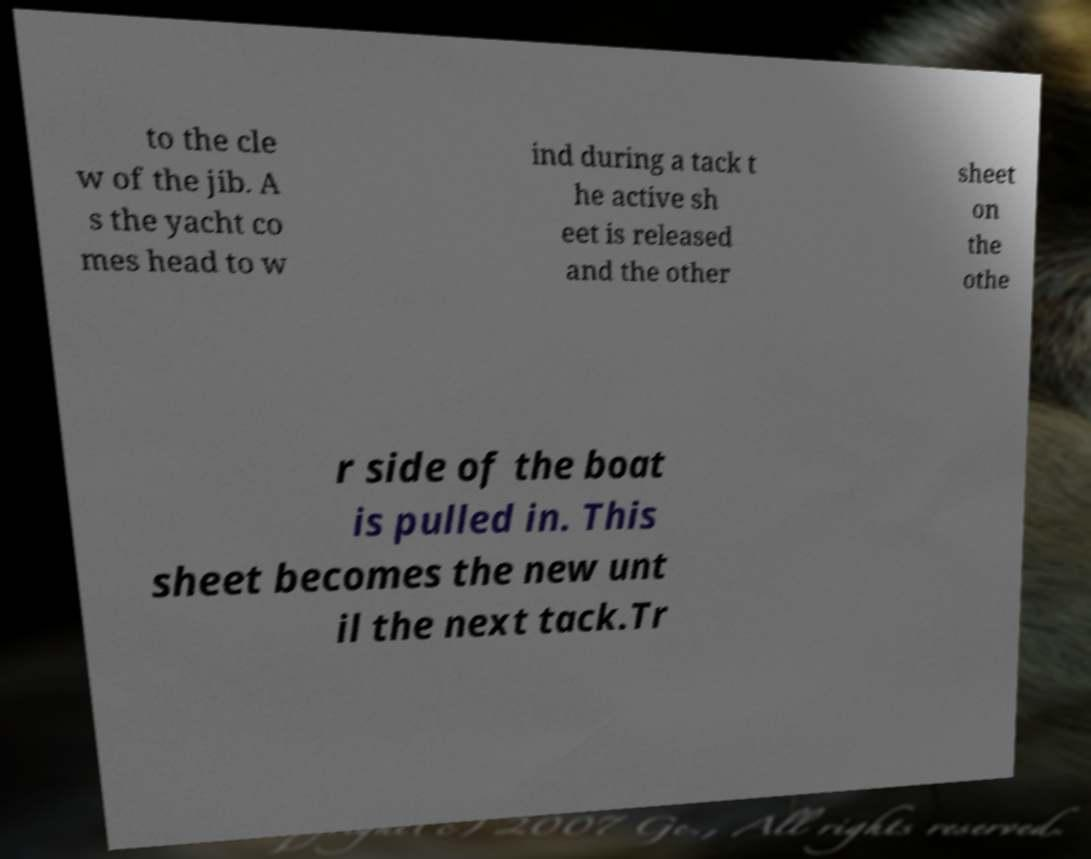Can you accurately transcribe the text from the provided image for me? to the cle w of the jib. A s the yacht co mes head to w ind during a tack t he active sh eet is released and the other sheet on the othe r side of the boat is pulled in. This sheet becomes the new unt il the next tack.Tr 